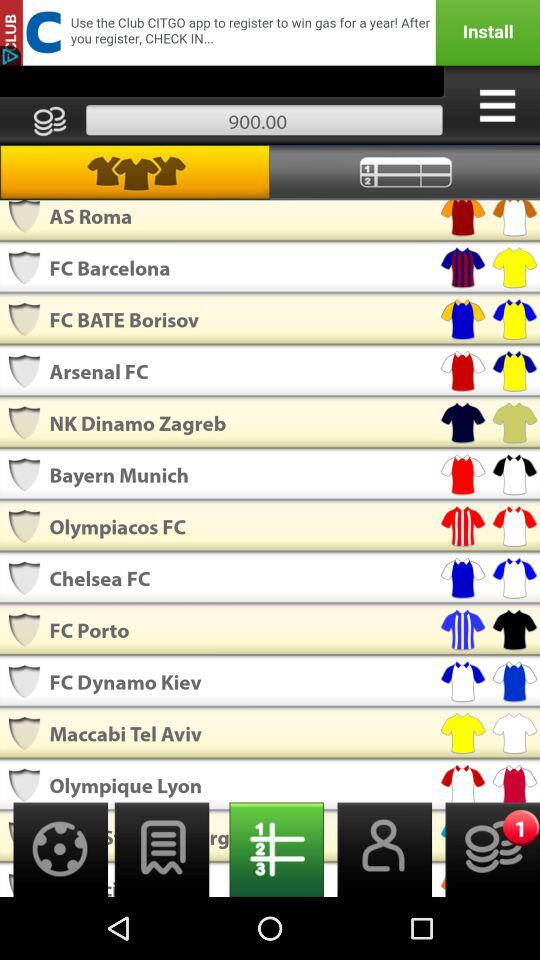Can you tell me more about the top three clubs listed in the image? The top three clubs listed in the image are AS Roma, FC Barcelona, and FC BATE Borisov. AS Roma is an Italian football club well-known for its rich history in Serie A. FC Barcelona, from Spain, is famous worldwide for its success, including multiple Champions League titles. FC BATE Borisov, though less globally recognized, is a leading football team in Belarus. Which club has the best record in European competitions? FC Barcelona has the best record in European competitions among the clubs listed. They have won multiple UEFA Champions League titles, often showcasing their strong tactical play and high-profile players. 